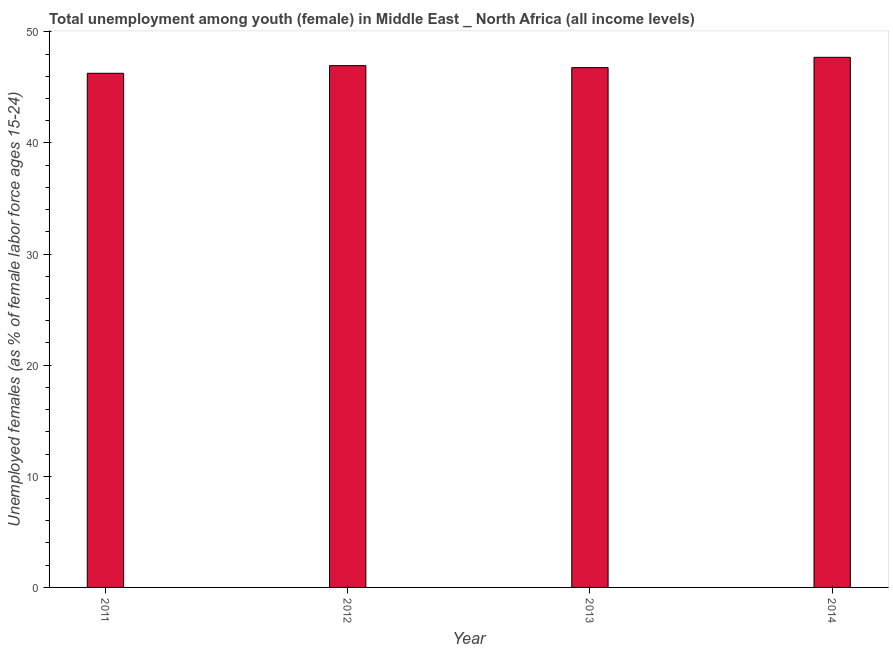What is the title of the graph?
Offer a very short reply. Total unemployment among youth (female) in Middle East _ North Africa (all income levels). What is the label or title of the Y-axis?
Keep it short and to the point. Unemployed females (as % of female labor force ages 15-24). What is the unemployed female youth population in 2011?
Ensure brevity in your answer.  46.27. Across all years, what is the maximum unemployed female youth population?
Ensure brevity in your answer.  47.7. Across all years, what is the minimum unemployed female youth population?
Keep it short and to the point. 46.27. What is the sum of the unemployed female youth population?
Your answer should be compact. 187.7. What is the difference between the unemployed female youth population in 2011 and 2014?
Make the answer very short. -1.44. What is the average unemployed female youth population per year?
Give a very brief answer. 46.92. What is the median unemployed female youth population?
Your response must be concise. 46.87. Do a majority of the years between 2014 and 2013 (inclusive) have unemployed female youth population greater than 18 %?
Provide a short and direct response. No. What is the ratio of the unemployed female youth population in 2011 to that in 2012?
Ensure brevity in your answer.  0.98. Is the difference between the unemployed female youth population in 2011 and 2012 greater than the difference between any two years?
Offer a terse response. No. What is the difference between the highest and the second highest unemployed female youth population?
Your response must be concise. 0.75. Is the sum of the unemployed female youth population in 2012 and 2013 greater than the maximum unemployed female youth population across all years?
Make the answer very short. Yes. What is the difference between the highest and the lowest unemployed female youth population?
Offer a very short reply. 1.44. How many years are there in the graph?
Make the answer very short. 4. What is the Unemployed females (as % of female labor force ages 15-24) of 2011?
Your response must be concise. 46.27. What is the Unemployed females (as % of female labor force ages 15-24) in 2012?
Your answer should be very brief. 46.96. What is the Unemployed females (as % of female labor force ages 15-24) in 2013?
Provide a succinct answer. 46.78. What is the Unemployed females (as % of female labor force ages 15-24) of 2014?
Keep it short and to the point. 47.7. What is the difference between the Unemployed females (as % of female labor force ages 15-24) in 2011 and 2012?
Give a very brief answer. -0.69. What is the difference between the Unemployed females (as % of female labor force ages 15-24) in 2011 and 2013?
Provide a short and direct response. -0.51. What is the difference between the Unemployed females (as % of female labor force ages 15-24) in 2011 and 2014?
Ensure brevity in your answer.  -1.44. What is the difference between the Unemployed females (as % of female labor force ages 15-24) in 2012 and 2013?
Make the answer very short. 0.18. What is the difference between the Unemployed females (as % of female labor force ages 15-24) in 2012 and 2014?
Offer a very short reply. -0.75. What is the difference between the Unemployed females (as % of female labor force ages 15-24) in 2013 and 2014?
Keep it short and to the point. -0.93. What is the ratio of the Unemployed females (as % of female labor force ages 15-24) in 2011 to that in 2013?
Make the answer very short. 0.99. What is the ratio of the Unemployed females (as % of female labor force ages 15-24) in 2011 to that in 2014?
Your answer should be very brief. 0.97. What is the ratio of the Unemployed females (as % of female labor force ages 15-24) in 2013 to that in 2014?
Your response must be concise. 0.98. 